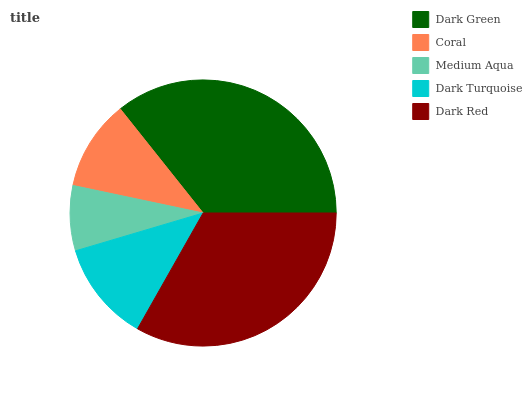Is Medium Aqua the minimum?
Answer yes or no. Yes. Is Dark Green the maximum?
Answer yes or no. Yes. Is Coral the minimum?
Answer yes or no. No. Is Coral the maximum?
Answer yes or no. No. Is Dark Green greater than Coral?
Answer yes or no. Yes. Is Coral less than Dark Green?
Answer yes or no. Yes. Is Coral greater than Dark Green?
Answer yes or no. No. Is Dark Green less than Coral?
Answer yes or no. No. Is Dark Turquoise the high median?
Answer yes or no. Yes. Is Dark Turquoise the low median?
Answer yes or no. Yes. Is Medium Aqua the high median?
Answer yes or no. No. Is Coral the low median?
Answer yes or no. No. 